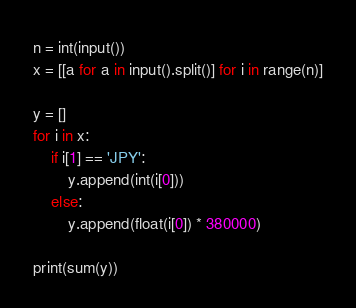Convert code to text. <code><loc_0><loc_0><loc_500><loc_500><_Python_>n = int(input())
x = [[a for a in input().split()] for i in range(n)]

y = []
for i in x:
    if i[1] == 'JPY':
        y.append(int(i[0]))
    else:
        y.append(float(i[0]) * 380000)

print(sum(y))
</code> 